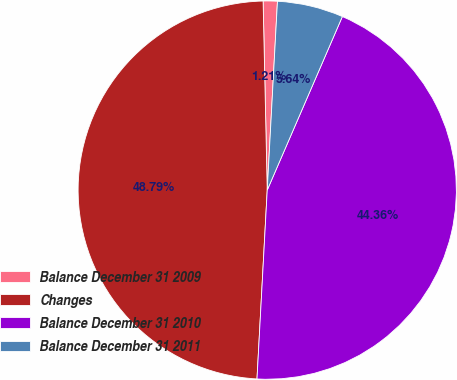<chart> <loc_0><loc_0><loc_500><loc_500><pie_chart><fcel>Balance December 31 2009<fcel>Changes<fcel>Balance December 31 2010<fcel>Balance December 31 2011<nl><fcel>1.21%<fcel>48.79%<fcel>44.36%<fcel>5.64%<nl></chart> 